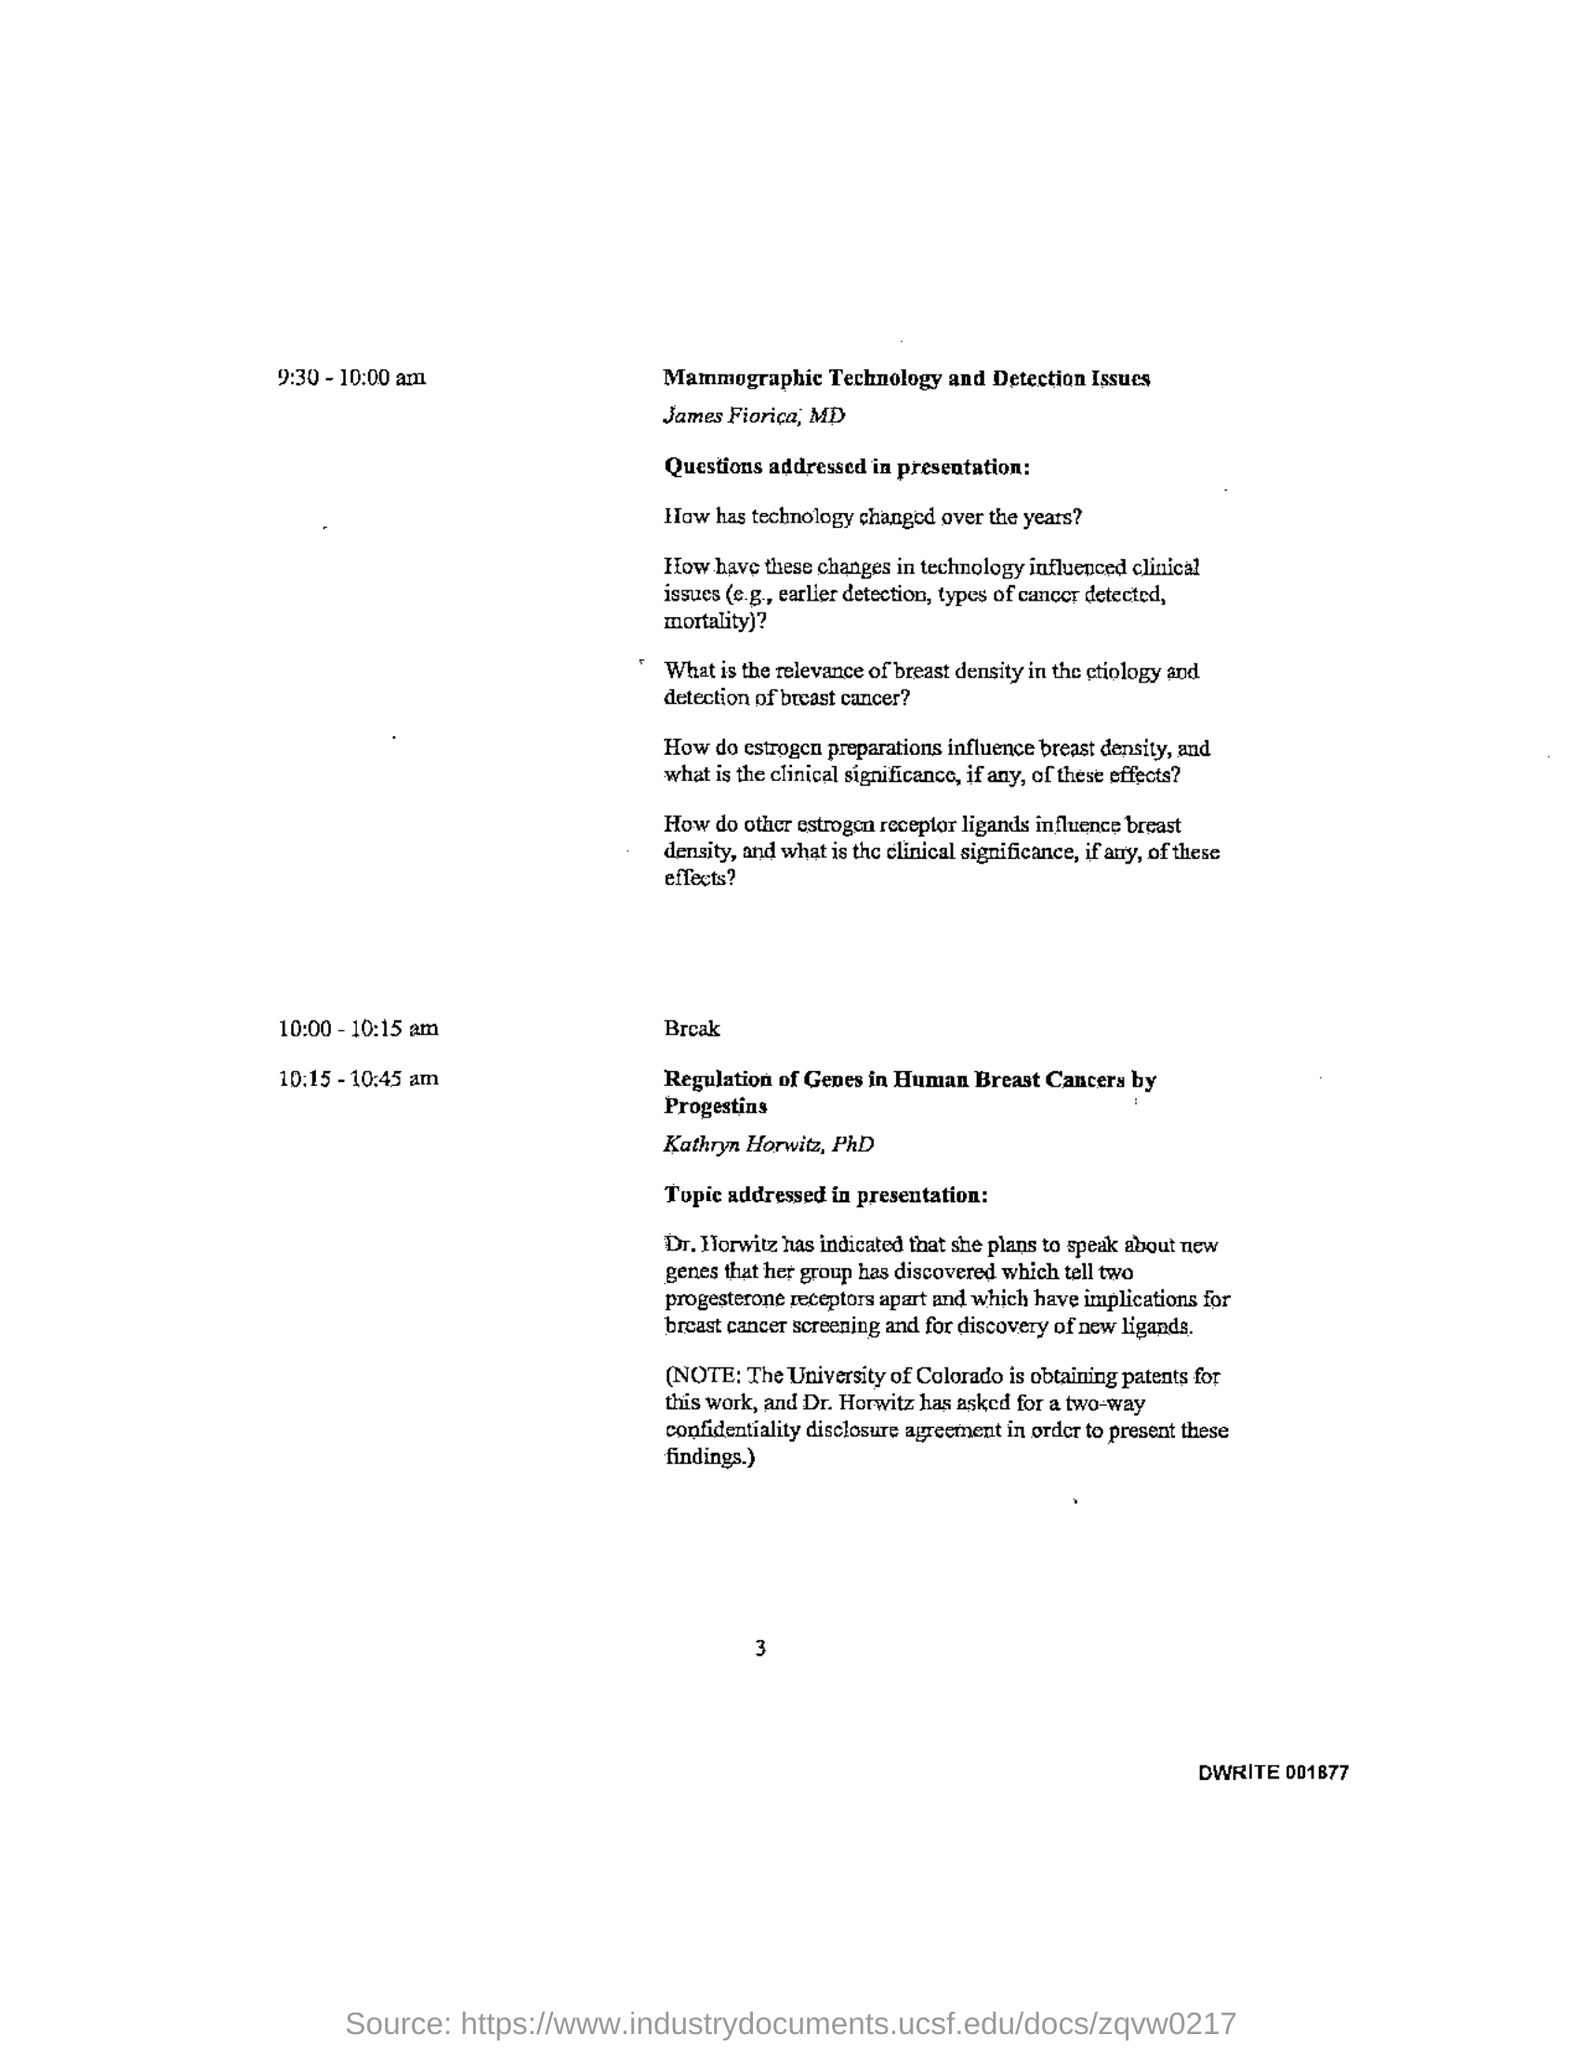When is the Break?
Provide a short and direct response. 10:00 - 10:15 am. What is the alphanumeric sequence given at the right bottom?
Provide a short and direct response. DWRITE 001877. 